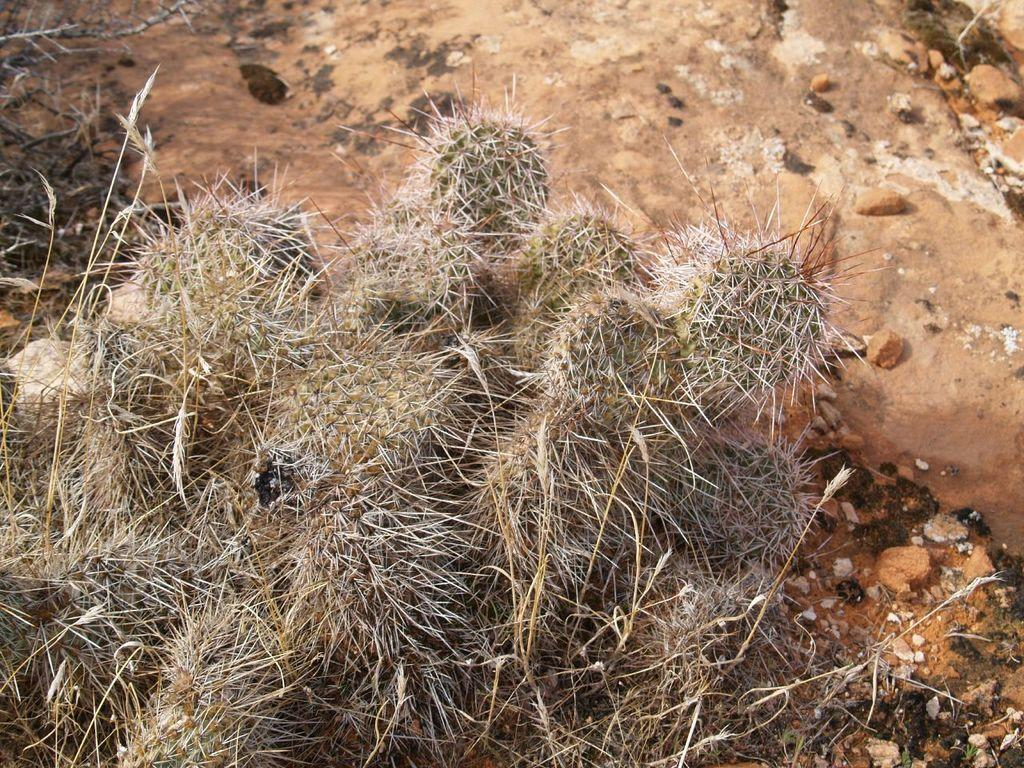What type of living organisms can be seen in the image? Plants can be seen in the image. What inorganic objects are present in the image? There are stones in the image. What type of hair can be seen on the plants in the image? There is no hair present on the plants in the image; plants do not have hair. Can you spot a bee buzzing around the plants in the image? There is no bee present in the image; only plants and stones are visible. 